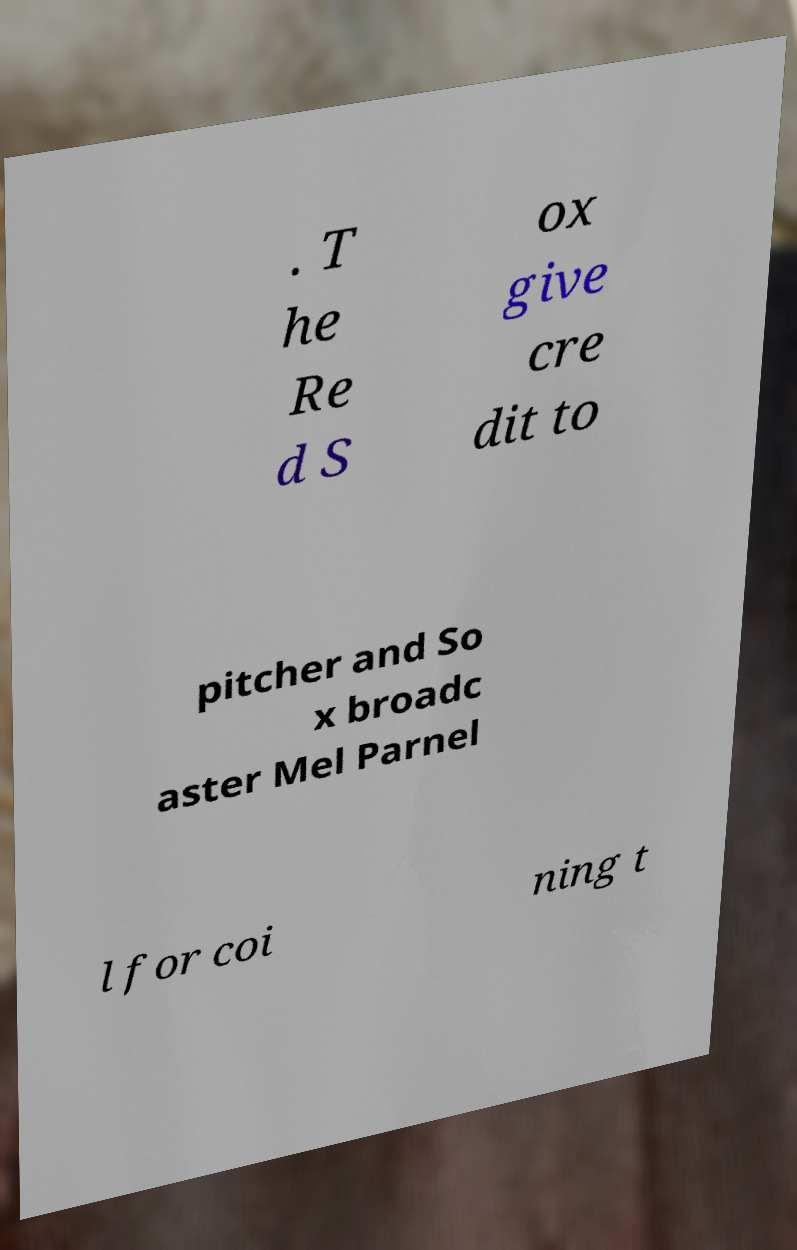Please read and relay the text visible in this image. What does it say? . T he Re d S ox give cre dit to pitcher and So x broadc aster Mel Parnel l for coi ning t 